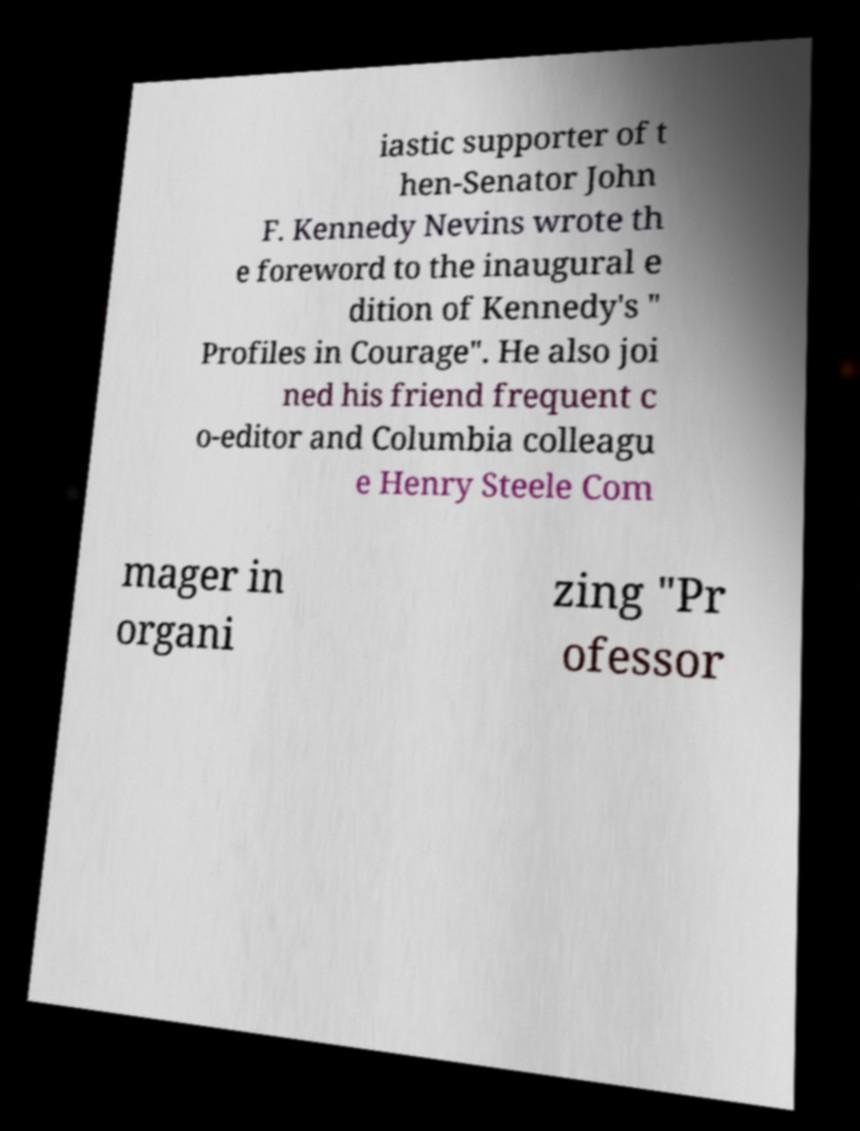I need the written content from this picture converted into text. Can you do that? iastic supporter of t hen-Senator John F. Kennedy Nevins wrote th e foreword to the inaugural e dition of Kennedy's " Profiles in Courage". He also joi ned his friend frequent c o-editor and Columbia colleagu e Henry Steele Com mager in organi zing "Pr ofessor 